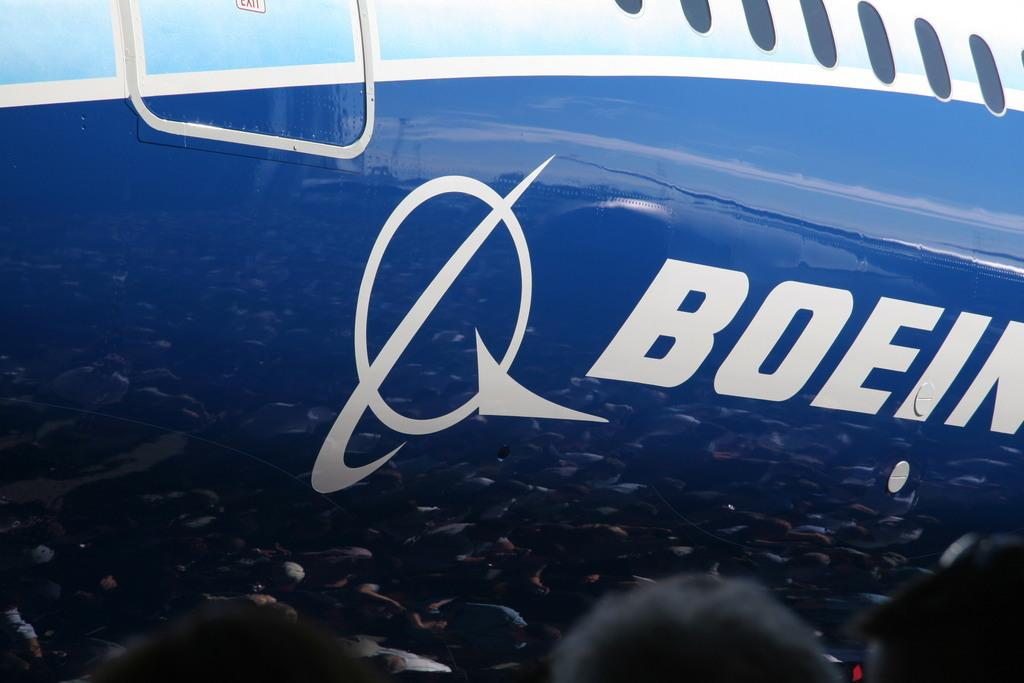Provide a one-sentence caption for the provided image. A blue, white and light blue plane with the words Boein and an emblem on the side. 